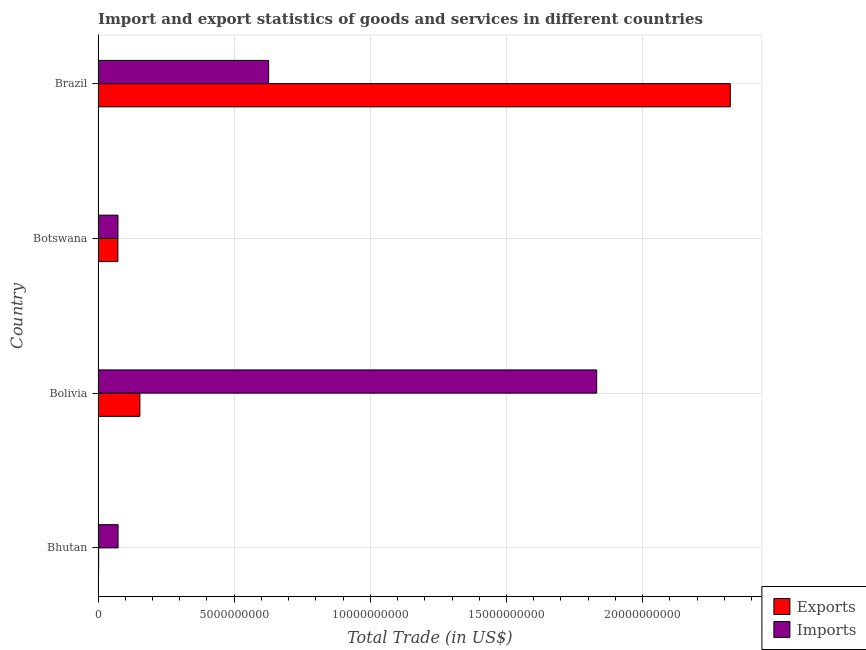How many groups of bars are there?
Make the answer very short. 4. Are the number of bars per tick equal to the number of legend labels?
Provide a succinct answer. Yes. How many bars are there on the 2nd tick from the top?
Keep it short and to the point. 2. How many bars are there on the 2nd tick from the bottom?
Keep it short and to the point. 2. What is the export of goods and services in Botswana?
Offer a terse response. 7.28e+08. Across all countries, what is the maximum imports of goods and services?
Offer a terse response. 1.83e+1. Across all countries, what is the minimum export of goods and services?
Offer a terse response. 2.00e+07. In which country was the imports of goods and services maximum?
Your response must be concise. Bolivia. In which country was the export of goods and services minimum?
Keep it short and to the point. Bhutan. What is the total imports of goods and services in the graph?
Your answer should be compact. 2.60e+1. What is the difference between the export of goods and services in Bhutan and that in Brazil?
Provide a short and direct response. -2.32e+1. What is the difference between the imports of goods and services in Brazil and the export of goods and services in Bolivia?
Your answer should be compact. 4.73e+09. What is the average export of goods and services per country?
Your response must be concise. 6.38e+09. What is the difference between the export of goods and services and imports of goods and services in Bolivia?
Your answer should be very brief. -1.68e+1. What is the ratio of the imports of goods and services in Bhutan to that in Botswana?
Give a very brief answer. 1. Is the difference between the export of goods and services in Bhutan and Bolivia greater than the difference between the imports of goods and services in Bhutan and Bolivia?
Provide a succinct answer. Yes. What is the difference between the highest and the second highest imports of goods and services?
Offer a very short reply. 1.20e+1. What is the difference between the highest and the lowest export of goods and services?
Offer a very short reply. 2.32e+1. In how many countries, is the imports of goods and services greater than the average imports of goods and services taken over all countries?
Offer a terse response. 1. What does the 1st bar from the top in Brazil represents?
Keep it short and to the point. Imports. What does the 1st bar from the bottom in Botswana represents?
Give a very brief answer. Exports. Are all the bars in the graph horizontal?
Give a very brief answer. Yes. How many countries are there in the graph?
Your answer should be very brief. 4. What is the difference between two consecutive major ticks on the X-axis?
Offer a very short reply. 5.00e+09. Does the graph contain grids?
Your answer should be very brief. Yes. How many legend labels are there?
Ensure brevity in your answer.  2. What is the title of the graph?
Offer a terse response. Import and export statistics of goods and services in different countries. Does "Fraud firms" appear as one of the legend labels in the graph?
Your answer should be compact. No. What is the label or title of the X-axis?
Ensure brevity in your answer.  Total Trade (in US$). What is the Total Trade (in US$) of Exports in Bhutan?
Offer a terse response. 2.00e+07. What is the Total Trade (in US$) of Imports in Bhutan?
Make the answer very short. 7.33e+08. What is the Total Trade (in US$) of Exports in Bolivia?
Ensure brevity in your answer.  1.54e+09. What is the Total Trade (in US$) in Imports in Bolivia?
Your response must be concise. 1.83e+1. What is the Total Trade (in US$) in Exports in Botswana?
Offer a terse response. 7.28e+08. What is the Total Trade (in US$) of Imports in Botswana?
Offer a very short reply. 7.30e+08. What is the Total Trade (in US$) in Exports in Brazil?
Make the answer very short. 2.32e+1. What is the Total Trade (in US$) in Imports in Brazil?
Your answer should be very brief. 6.26e+09. Across all countries, what is the maximum Total Trade (in US$) of Exports?
Your answer should be very brief. 2.32e+1. Across all countries, what is the maximum Total Trade (in US$) of Imports?
Give a very brief answer. 1.83e+1. Across all countries, what is the minimum Total Trade (in US$) in Exports?
Make the answer very short. 2.00e+07. Across all countries, what is the minimum Total Trade (in US$) in Imports?
Ensure brevity in your answer.  7.30e+08. What is the total Total Trade (in US$) in Exports in the graph?
Make the answer very short. 2.55e+1. What is the total Total Trade (in US$) in Imports in the graph?
Your answer should be very brief. 2.60e+1. What is the difference between the Total Trade (in US$) of Exports in Bhutan and that in Bolivia?
Ensure brevity in your answer.  -1.52e+09. What is the difference between the Total Trade (in US$) in Imports in Bhutan and that in Bolivia?
Provide a short and direct response. -1.76e+1. What is the difference between the Total Trade (in US$) in Exports in Bhutan and that in Botswana?
Your answer should be very brief. -7.08e+08. What is the difference between the Total Trade (in US$) in Imports in Bhutan and that in Botswana?
Your answer should be very brief. 3.65e+06. What is the difference between the Total Trade (in US$) in Exports in Bhutan and that in Brazil?
Give a very brief answer. -2.32e+1. What is the difference between the Total Trade (in US$) in Imports in Bhutan and that in Brazil?
Ensure brevity in your answer.  -5.53e+09. What is the difference between the Total Trade (in US$) of Exports in Bolivia and that in Botswana?
Your answer should be compact. 8.08e+08. What is the difference between the Total Trade (in US$) in Imports in Bolivia and that in Botswana?
Give a very brief answer. 1.76e+1. What is the difference between the Total Trade (in US$) in Exports in Bolivia and that in Brazil?
Ensure brevity in your answer.  -2.17e+1. What is the difference between the Total Trade (in US$) of Imports in Bolivia and that in Brazil?
Your answer should be compact. 1.20e+1. What is the difference between the Total Trade (in US$) in Exports in Botswana and that in Brazil?
Your answer should be very brief. -2.25e+1. What is the difference between the Total Trade (in US$) of Imports in Botswana and that in Brazil?
Make the answer very short. -5.53e+09. What is the difference between the Total Trade (in US$) in Exports in Bhutan and the Total Trade (in US$) in Imports in Bolivia?
Keep it short and to the point. -1.83e+1. What is the difference between the Total Trade (in US$) in Exports in Bhutan and the Total Trade (in US$) in Imports in Botswana?
Your answer should be very brief. -7.10e+08. What is the difference between the Total Trade (in US$) of Exports in Bhutan and the Total Trade (in US$) of Imports in Brazil?
Provide a short and direct response. -6.24e+09. What is the difference between the Total Trade (in US$) in Exports in Bolivia and the Total Trade (in US$) in Imports in Botswana?
Offer a terse response. 8.06e+08. What is the difference between the Total Trade (in US$) of Exports in Bolivia and the Total Trade (in US$) of Imports in Brazil?
Offer a terse response. -4.73e+09. What is the difference between the Total Trade (in US$) in Exports in Botswana and the Total Trade (in US$) in Imports in Brazil?
Make the answer very short. -5.54e+09. What is the average Total Trade (in US$) of Exports per country?
Ensure brevity in your answer.  6.38e+09. What is the average Total Trade (in US$) of Imports per country?
Offer a very short reply. 6.51e+09. What is the difference between the Total Trade (in US$) in Exports and Total Trade (in US$) in Imports in Bhutan?
Keep it short and to the point. -7.13e+08. What is the difference between the Total Trade (in US$) in Exports and Total Trade (in US$) in Imports in Bolivia?
Provide a succinct answer. -1.68e+1. What is the difference between the Total Trade (in US$) of Exports and Total Trade (in US$) of Imports in Botswana?
Give a very brief answer. -2.01e+06. What is the difference between the Total Trade (in US$) of Exports and Total Trade (in US$) of Imports in Brazil?
Ensure brevity in your answer.  1.70e+1. What is the ratio of the Total Trade (in US$) of Exports in Bhutan to that in Bolivia?
Provide a short and direct response. 0.01. What is the ratio of the Total Trade (in US$) in Exports in Bhutan to that in Botswana?
Your response must be concise. 0.03. What is the ratio of the Total Trade (in US$) in Imports in Bhutan to that in Botswana?
Provide a succinct answer. 1. What is the ratio of the Total Trade (in US$) of Exports in Bhutan to that in Brazil?
Offer a terse response. 0. What is the ratio of the Total Trade (in US$) of Imports in Bhutan to that in Brazil?
Your response must be concise. 0.12. What is the ratio of the Total Trade (in US$) of Exports in Bolivia to that in Botswana?
Keep it short and to the point. 2.11. What is the ratio of the Total Trade (in US$) in Imports in Bolivia to that in Botswana?
Give a very brief answer. 25.1. What is the ratio of the Total Trade (in US$) of Exports in Bolivia to that in Brazil?
Your answer should be very brief. 0.07. What is the ratio of the Total Trade (in US$) of Imports in Bolivia to that in Brazil?
Make the answer very short. 2.92. What is the ratio of the Total Trade (in US$) of Exports in Botswana to that in Brazil?
Offer a terse response. 0.03. What is the ratio of the Total Trade (in US$) in Imports in Botswana to that in Brazil?
Your answer should be compact. 0.12. What is the difference between the highest and the second highest Total Trade (in US$) in Exports?
Your answer should be compact. 2.17e+1. What is the difference between the highest and the second highest Total Trade (in US$) of Imports?
Make the answer very short. 1.20e+1. What is the difference between the highest and the lowest Total Trade (in US$) of Exports?
Your answer should be compact. 2.32e+1. What is the difference between the highest and the lowest Total Trade (in US$) of Imports?
Provide a succinct answer. 1.76e+1. 